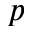<formula> <loc_0><loc_0><loc_500><loc_500>p</formula> 